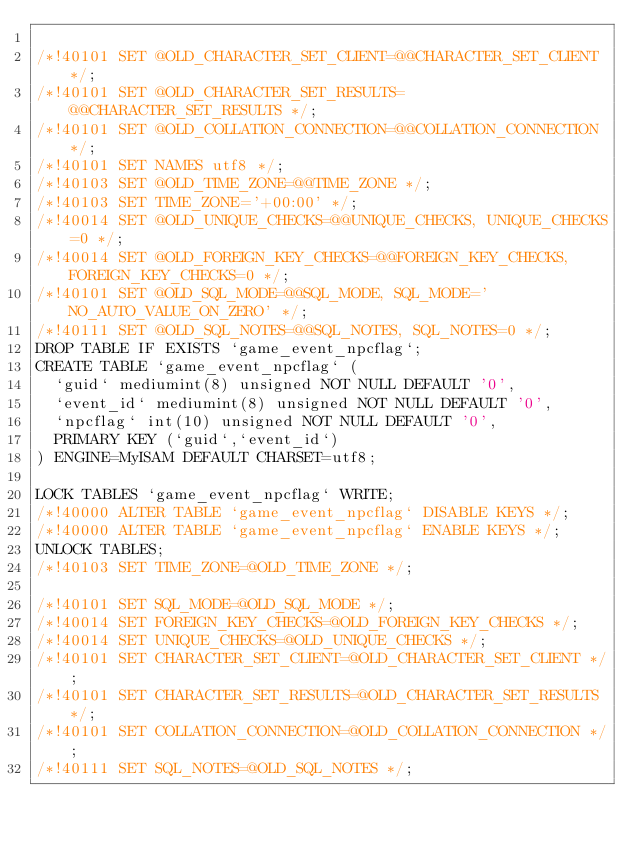<code> <loc_0><loc_0><loc_500><loc_500><_SQL_>
/*!40101 SET @OLD_CHARACTER_SET_CLIENT=@@CHARACTER_SET_CLIENT */;
/*!40101 SET @OLD_CHARACTER_SET_RESULTS=@@CHARACTER_SET_RESULTS */;
/*!40101 SET @OLD_COLLATION_CONNECTION=@@COLLATION_CONNECTION */;
/*!40101 SET NAMES utf8 */;
/*!40103 SET @OLD_TIME_ZONE=@@TIME_ZONE */;
/*!40103 SET TIME_ZONE='+00:00' */;
/*!40014 SET @OLD_UNIQUE_CHECKS=@@UNIQUE_CHECKS, UNIQUE_CHECKS=0 */;
/*!40014 SET @OLD_FOREIGN_KEY_CHECKS=@@FOREIGN_KEY_CHECKS, FOREIGN_KEY_CHECKS=0 */;
/*!40101 SET @OLD_SQL_MODE=@@SQL_MODE, SQL_MODE='NO_AUTO_VALUE_ON_ZERO' */;
/*!40111 SET @OLD_SQL_NOTES=@@SQL_NOTES, SQL_NOTES=0 */;
DROP TABLE IF EXISTS `game_event_npcflag`;
CREATE TABLE `game_event_npcflag` (
  `guid` mediumint(8) unsigned NOT NULL DEFAULT '0',
  `event_id` mediumint(8) unsigned NOT NULL DEFAULT '0',
  `npcflag` int(10) unsigned NOT NULL DEFAULT '0',
  PRIMARY KEY (`guid`,`event_id`)
) ENGINE=MyISAM DEFAULT CHARSET=utf8;

LOCK TABLES `game_event_npcflag` WRITE;
/*!40000 ALTER TABLE `game_event_npcflag` DISABLE KEYS */;
/*!40000 ALTER TABLE `game_event_npcflag` ENABLE KEYS */;
UNLOCK TABLES;
/*!40103 SET TIME_ZONE=@OLD_TIME_ZONE */;

/*!40101 SET SQL_MODE=@OLD_SQL_MODE */;
/*!40014 SET FOREIGN_KEY_CHECKS=@OLD_FOREIGN_KEY_CHECKS */;
/*!40014 SET UNIQUE_CHECKS=@OLD_UNIQUE_CHECKS */;
/*!40101 SET CHARACTER_SET_CLIENT=@OLD_CHARACTER_SET_CLIENT */;
/*!40101 SET CHARACTER_SET_RESULTS=@OLD_CHARACTER_SET_RESULTS */;
/*!40101 SET COLLATION_CONNECTION=@OLD_COLLATION_CONNECTION */;
/*!40111 SET SQL_NOTES=@OLD_SQL_NOTES */;

</code> 